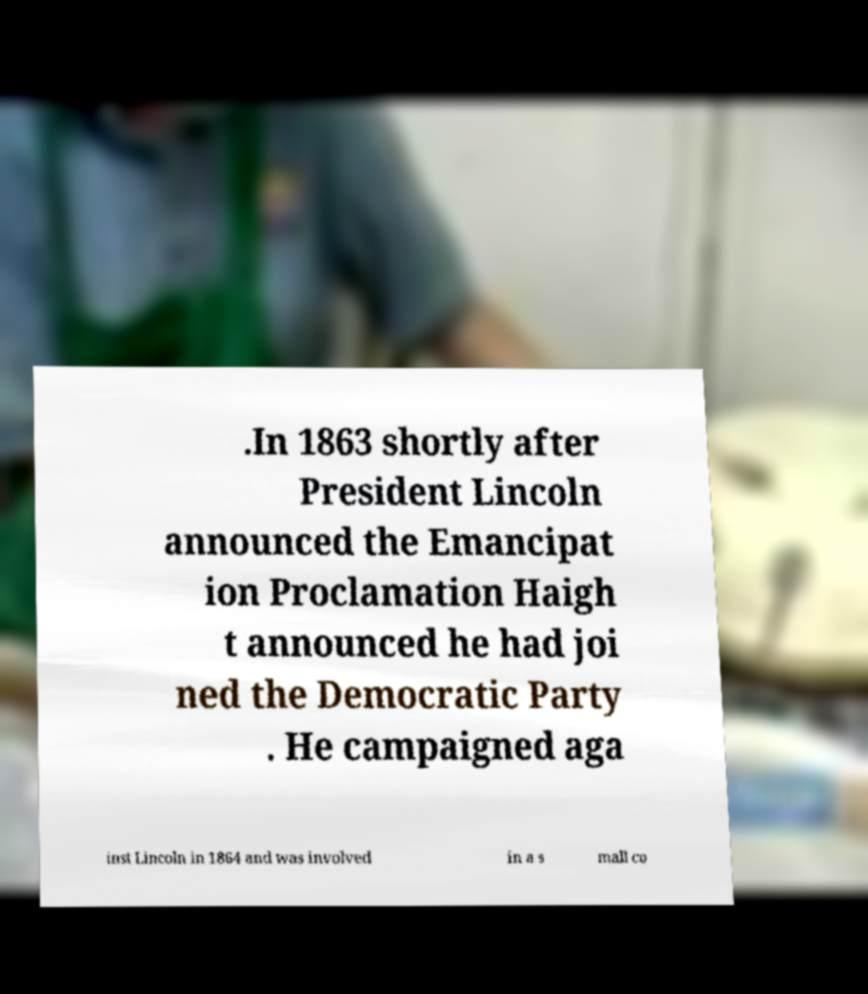Could you assist in decoding the text presented in this image and type it out clearly? .In 1863 shortly after President Lincoln announced the Emancipat ion Proclamation Haigh t announced he had joi ned the Democratic Party . He campaigned aga inst Lincoln in 1864 and was involved in a s mall co 